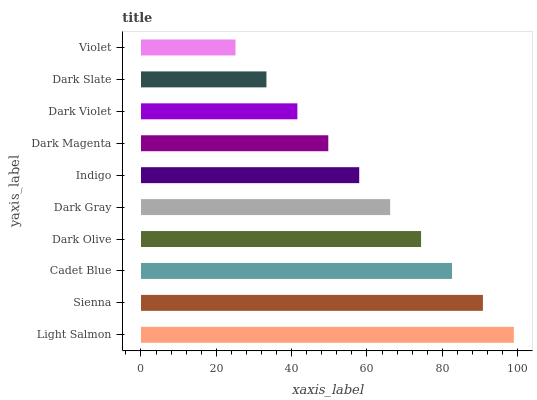Is Violet the minimum?
Answer yes or no. Yes. Is Light Salmon the maximum?
Answer yes or no. Yes. Is Sienna the minimum?
Answer yes or no. No. Is Sienna the maximum?
Answer yes or no. No. Is Light Salmon greater than Sienna?
Answer yes or no. Yes. Is Sienna less than Light Salmon?
Answer yes or no. Yes. Is Sienna greater than Light Salmon?
Answer yes or no. No. Is Light Salmon less than Sienna?
Answer yes or no. No. Is Dark Gray the high median?
Answer yes or no. Yes. Is Indigo the low median?
Answer yes or no. Yes. Is Sienna the high median?
Answer yes or no. No. Is Dark Violet the low median?
Answer yes or no. No. 